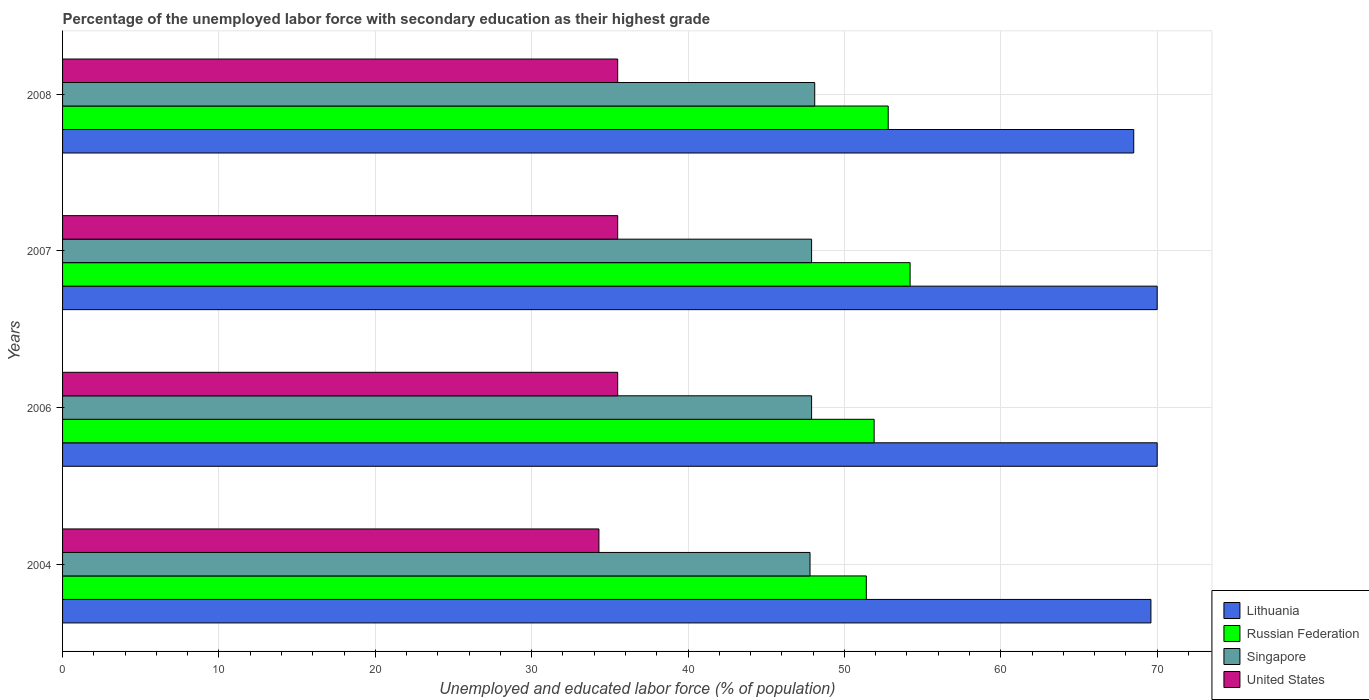Are the number of bars on each tick of the Y-axis equal?
Your answer should be compact. Yes. How many bars are there on the 4th tick from the top?
Make the answer very short. 4. What is the label of the 3rd group of bars from the top?
Keep it short and to the point. 2006. What is the percentage of the unemployed labor force with secondary education in Russian Federation in 2007?
Provide a succinct answer. 54.2. Across all years, what is the minimum percentage of the unemployed labor force with secondary education in Singapore?
Your response must be concise. 47.8. In which year was the percentage of the unemployed labor force with secondary education in Lithuania minimum?
Your answer should be compact. 2008. What is the total percentage of the unemployed labor force with secondary education in Singapore in the graph?
Provide a short and direct response. 191.7. What is the difference between the percentage of the unemployed labor force with secondary education in Singapore in 2006 and that in 2007?
Provide a short and direct response. 0. What is the difference between the percentage of the unemployed labor force with secondary education in United States in 2004 and the percentage of the unemployed labor force with secondary education in Singapore in 2007?
Offer a terse response. -13.6. What is the average percentage of the unemployed labor force with secondary education in Russian Federation per year?
Provide a short and direct response. 52.58. In the year 2006, what is the difference between the percentage of the unemployed labor force with secondary education in Lithuania and percentage of the unemployed labor force with secondary education in United States?
Make the answer very short. 34.5. In how many years, is the percentage of the unemployed labor force with secondary education in Singapore greater than 24 %?
Your response must be concise. 4. What is the ratio of the percentage of the unemployed labor force with secondary education in Russian Federation in 2004 to that in 2006?
Give a very brief answer. 0.99. In how many years, is the percentage of the unemployed labor force with secondary education in United States greater than the average percentage of the unemployed labor force with secondary education in United States taken over all years?
Provide a succinct answer. 3. What does the 4th bar from the top in 2008 represents?
Offer a very short reply. Lithuania. What does the 2nd bar from the bottom in 2008 represents?
Your response must be concise. Russian Federation. How many bars are there?
Keep it short and to the point. 16. How many years are there in the graph?
Provide a succinct answer. 4. Are the values on the major ticks of X-axis written in scientific E-notation?
Offer a terse response. No. Does the graph contain any zero values?
Offer a very short reply. No. Does the graph contain grids?
Your response must be concise. Yes. What is the title of the graph?
Offer a terse response. Percentage of the unemployed labor force with secondary education as their highest grade. Does "Tunisia" appear as one of the legend labels in the graph?
Your answer should be compact. No. What is the label or title of the X-axis?
Offer a terse response. Unemployed and educated labor force (% of population). What is the Unemployed and educated labor force (% of population) in Lithuania in 2004?
Offer a terse response. 69.6. What is the Unemployed and educated labor force (% of population) of Russian Federation in 2004?
Your answer should be very brief. 51.4. What is the Unemployed and educated labor force (% of population) in Singapore in 2004?
Your answer should be very brief. 47.8. What is the Unemployed and educated labor force (% of population) in United States in 2004?
Give a very brief answer. 34.3. What is the Unemployed and educated labor force (% of population) of Lithuania in 2006?
Provide a succinct answer. 70. What is the Unemployed and educated labor force (% of population) in Russian Federation in 2006?
Ensure brevity in your answer.  51.9. What is the Unemployed and educated labor force (% of population) of Singapore in 2006?
Ensure brevity in your answer.  47.9. What is the Unemployed and educated labor force (% of population) of United States in 2006?
Provide a succinct answer. 35.5. What is the Unemployed and educated labor force (% of population) of Russian Federation in 2007?
Ensure brevity in your answer.  54.2. What is the Unemployed and educated labor force (% of population) in Singapore in 2007?
Keep it short and to the point. 47.9. What is the Unemployed and educated labor force (% of population) in United States in 2007?
Make the answer very short. 35.5. What is the Unemployed and educated labor force (% of population) of Lithuania in 2008?
Make the answer very short. 68.5. What is the Unemployed and educated labor force (% of population) in Russian Federation in 2008?
Make the answer very short. 52.8. What is the Unemployed and educated labor force (% of population) in Singapore in 2008?
Give a very brief answer. 48.1. What is the Unemployed and educated labor force (% of population) of United States in 2008?
Offer a terse response. 35.5. Across all years, what is the maximum Unemployed and educated labor force (% of population) in Lithuania?
Provide a succinct answer. 70. Across all years, what is the maximum Unemployed and educated labor force (% of population) in Russian Federation?
Provide a short and direct response. 54.2. Across all years, what is the maximum Unemployed and educated labor force (% of population) in Singapore?
Ensure brevity in your answer.  48.1. Across all years, what is the maximum Unemployed and educated labor force (% of population) in United States?
Provide a succinct answer. 35.5. Across all years, what is the minimum Unemployed and educated labor force (% of population) of Lithuania?
Provide a short and direct response. 68.5. Across all years, what is the minimum Unemployed and educated labor force (% of population) in Russian Federation?
Your response must be concise. 51.4. Across all years, what is the minimum Unemployed and educated labor force (% of population) of Singapore?
Your response must be concise. 47.8. Across all years, what is the minimum Unemployed and educated labor force (% of population) in United States?
Offer a very short reply. 34.3. What is the total Unemployed and educated labor force (% of population) in Lithuania in the graph?
Offer a very short reply. 278.1. What is the total Unemployed and educated labor force (% of population) in Russian Federation in the graph?
Give a very brief answer. 210.3. What is the total Unemployed and educated labor force (% of population) in Singapore in the graph?
Offer a very short reply. 191.7. What is the total Unemployed and educated labor force (% of population) of United States in the graph?
Provide a short and direct response. 140.8. What is the difference between the Unemployed and educated labor force (% of population) in Lithuania in 2004 and that in 2006?
Make the answer very short. -0.4. What is the difference between the Unemployed and educated labor force (% of population) in Russian Federation in 2004 and that in 2006?
Give a very brief answer. -0.5. What is the difference between the Unemployed and educated labor force (% of population) of Lithuania in 2004 and that in 2007?
Make the answer very short. -0.4. What is the difference between the Unemployed and educated labor force (% of population) in Russian Federation in 2004 and that in 2007?
Provide a succinct answer. -2.8. What is the difference between the Unemployed and educated labor force (% of population) of United States in 2004 and that in 2007?
Provide a short and direct response. -1.2. What is the difference between the Unemployed and educated labor force (% of population) of Singapore in 2004 and that in 2008?
Provide a short and direct response. -0.3. What is the difference between the Unemployed and educated labor force (% of population) of Russian Federation in 2006 and that in 2007?
Offer a very short reply. -2.3. What is the difference between the Unemployed and educated labor force (% of population) in Lithuania in 2006 and that in 2008?
Ensure brevity in your answer.  1.5. What is the difference between the Unemployed and educated labor force (% of population) in Singapore in 2007 and that in 2008?
Make the answer very short. -0.2. What is the difference between the Unemployed and educated labor force (% of population) of Lithuania in 2004 and the Unemployed and educated labor force (% of population) of Russian Federation in 2006?
Offer a terse response. 17.7. What is the difference between the Unemployed and educated labor force (% of population) in Lithuania in 2004 and the Unemployed and educated labor force (% of population) in Singapore in 2006?
Ensure brevity in your answer.  21.7. What is the difference between the Unemployed and educated labor force (% of population) in Lithuania in 2004 and the Unemployed and educated labor force (% of population) in United States in 2006?
Your answer should be compact. 34.1. What is the difference between the Unemployed and educated labor force (% of population) in Lithuania in 2004 and the Unemployed and educated labor force (% of population) in Russian Federation in 2007?
Ensure brevity in your answer.  15.4. What is the difference between the Unemployed and educated labor force (% of population) of Lithuania in 2004 and the Unemployed and educated labor force (% of population) of Singapore in 2007?
Your response must be concise. 21.7. What is the difference between the Unemployed and educated labor force (% of population) in Lithuania in 2004 and the Unemployed and educated labor force (% of population) in United States in 2007?
Offer a very short reply. 34.1. What is the difference between the Unemployed and educated labor force (% of population) in Russian Federation in 2004 and the Unemployed and educated labor force (% of population) in United States in 2007?
Your answer should be very brief. 15.9. What is the difference between the Unemployed and educated labor force (% of population) in Lithuania in 2004 and the Unemployed and educated labor force (% of population) in Russian Federation in 2008?
Provide a short and direct response. 16.8. What is the difference between the Unemployed and educated labor force (% of population) of Lithuania in 2004 and the Unemployed and educated labor force (% of population) of Singapore in 2008?
Ensure brevity in your answer.  21.5. What is the difference between the Unemployed and educated labor force (% of population) of Lithuania in 2004 and the Unemployed and educated labor force (% of population) of United States in 2008?
Keep it short and to the point. 34.1. What is the difference between the Unemployed and educated labor force (% of population) of Lithuania in 2006 and the Unemployed and educated labor force (% of population) of Russian Federation in 2007?
Offer a very short reply. 15.8. What is the difference between the Unemployed and educated labor force (% of population) in Lithuania in 2006 and the Unemployed and educated labor force (% of population) in Singapore in 2007?
Your answer should be compact. 22.1. What is the difference between the Unemployed and educated labor force (% of population) in Lithuania in 2006 and the Unemployed and educated labor force (% of population) in United States in 2007?
Provide a short and direct response. 34.5. What is the difference between the Unemployed and educated labor force (% of population) of Russian Federation in 2006 and the Unemployed and educated labor force (% of population) of Singapore in 2007?
Your answer should be compact. 4. What is the difference between the Unemployed and educated labor force (% of population) in Singapore in 2006 and the Unemployed and educated labor force (% of population) in United States in 2007?
Provide a short and direct response. 12.4. What is the difference between the Unemployed and educated labor force (% of population) of Lithuania in 2006 and the Unemployed and educated labor force (% of population) of Singapore in 2008?
Provide a short and direct response. 21.9. What is the difference between the Unemployed and educated labor force (% of population) in Lithuania in 2006 and the Unemployed and educated labor force (% of population) in United States in 2008?
Your answer should be compact. 34.5. What is the difference between the Unemployed and educated labor force (% of population) in Lithuania in 2007 and the Unemployed and educated labor force (% of population) in Singapore in 2008?
Your answer should be very brief. 21.9. What is the difference between the Unemployed and educated labor force (% of population) in Lithuania in 2007 and the Unemployed and educated labor force (% of population) in United States in 2008?
Keep it short and to the point. 34.5. What is the difference between the Unemployed and educated labor force (% of population) in Russian Federation in 2007 and the Unemployed and educated labor force (% of population) in Singapore in 2008?
Provide a succinct answer. 6.1. What is the difference between the Unemployed and educated labor force (% of population) of Russian Federation in 2007 and the Unemployed and educated labor force (% of population) of United States in 2008?
Make the answer very short. 18.7. What is the average Unemployed and educated labor force (% of population) in Lithuania per year?
Your answer should be compact. 69.53. What is the average Unemployed and educated labor force (% of population) of Russian Federation per year?
Your response must be concise. 52.58. What is the average Unemployed and educated labor force (% of population) in Singapore per year?
Ensure brevity in your answer.  47.92. What is the average Unemployed and educated labor force (% of population) in United States per year?
Give a very brief answer. 35.2. In the year 2004, what is the difference between the Unemployed and educated labor force (% of population) in Lithuania and Unemployed and educated labor force (% of population) in Singapore?
Your response must be concise. 21.8. In the year 2004, what is the difference between the Unemployed and educated labor force (% of population) of Lithuania and Unemployed and educated labor force (% of population) of United States?
Keep it short and to the point. 35.3. In the year 2004, what is the difference between the Unemployed and educated labor force (% of population) in Russian Federation and Unemployed and educated labor force (% of population) in Singapore?
Your answer should be very brief. 3.6. In the year 2006, what is the difference between the Unemployed and educated labor force (% of population) of Lithuania and Unemployed and educated labor force (% of population) of Singapore?
Provide a short and direct response. 22.1. In the year 2006, what is the difference between the Unemployed and educated labor force (% of population) in Lithuania and Unemployed and educated labor force (% of population) in United States?
Keep it short and to the point. 34.5. In the year 2006, what is the difference between the Unemployed and educated labor force (% of population) in Russian Federation and Unemployed and educated labor force (% of population) in United States?
Your answer should be compact. 16.4. In the year 2007, what is the difference between the Unemployed and educated labor force (% of population) in Lithuania and Unemployed and educated labor force (% of population) in Russian Federation?
Make the answer very short. 15.8. In the year 2007, what is the difference between the Unemployed and educated labor force (% of population) of Lithuania and Unemployed and educated labor force (% of population) of Singapore?
Offer a very short reply. 22.1. In the year 2007, what is the difference between the Unemployed and educated labor force (% of population) of Lithuania and Unemployed and educated labor force (% of population) of United States?
Offer a terse response. 34.5. In the year 2007, what is the difference between the Unemployed and educated labor force (% of population) in Russian Federation and Unemployed and educated labor force (% of population) in Singapore?
Make the answer very short. 6.3. In the year 2007, what is the difference between the Unemployed and educated labor force (% of population) in Russian Federation and Unemployed and educated labor force (% of population) in United States?
Your answer should be very brief. 18.7. In the year 2007, what is the difference between the Unemployed and educated labor force (% of population) of Singapore and Unemployed and educated labor force (% of population) of United States?
Make the answer very short. 12.4. In the year 2008, what is the difference between the Unemployed and educated labor force (% of population) of Lithuania and Unemployed and educated labor force (% of population) of Singapore?
Your response must be concise. 20.4. In the year 2008, what is the difference between the Unemployed and educated labor force (% of population) of Russian Federation and Unemployed and educated labor force (% of population) of United States?
Offer a terse response. 17.3. In the year 2008, what is the difference between the Unemployed and educated labor force (% of population) in Singapore and Unemployed and educated labor force (% of population) in United States?
Keep it short and to the point. 12.6. What is the ratio of the Unemployed and educated labor force (% of population) of Singapore in 2004 to that in 2006?
Your response must be concise. 1. What is the ratio of the Unemployed and educated labor force (% of population) of United States in 2004 to that in 2006?
Make the answer very short. 0.97. What is the ratio of the Unemployed and educated labor force (% of population) in Russian Federation in 2004 to that in 2007?
Your response must be concise. 0.95. What is the ratio of the Unemployed and educated labor force (% of population) of Singapore in 2004 to that in 2007?
Keep it short and to the point. 1. What is the ratio of the Unemployed and educated labor force (% of population) of United States in 2004 to that in 2007?
Make the answer very short. 0.97. What is the ratio of the Unemployed and educated labor force (% of population) in Lithuania in 2004 to that in 2008?
Your response must be concise. 1.02. What is the ratio of the Unemployed and educated labor force (% of population) of Russian Federation in 2004 to that in 2008?
Your answer should be very brief. 0.97. What is the ratio of the Unemployed and educated labor force (% of population) in United States in 2004 to that in 2008?
Keep it short and to the point. 0.97. What is the ratio of the Unemployed and educated labor force (% of population) in Russian Federation in 2006 to that in 2007?
Your answer should be compact. 0.96. What is the ratio of the Unemployed and educated labor force (% of population) of Singapore in 2006 to that in 2007?
Provide a succinct answer. 1. What is the ratio of the Unemployed and educated labor force (% of population) in Lithuania in 2006 to that in 2008?
Make the answer very short. 1.02. What is the ratio of the Unemployed and educated labor force (% of population) in Lithuania in 2007 to that in 2008?
Your response must be concise. 1.02. What is the ratio of the Unemployed and educated labor force (% of population) in Russian Federation in 2007 to that in 2008?
Offer a terse response. 1.03. What is the ratio of the Unemployed and educated labor force (% of population) in Singapore in 2007 to that in 2008?
Your answer should be very brief. 1. What is the ratio of the Unemployed and educated labor force (% of population) in United States in 2007 to that in 2008?
Offer a terse response. 1. What is the difference between the highest and the second highest Unemployed and educated labor force (% of population) of Singapore?
Ensure brevity in your answer.  0.2. What is the difference between the highest and the second highest Unemployed and educated labor force (% of population) of United States?
Ensure brevity in your answer.  0. What is the difference between the highest and the lowest Unemployed and educated labor force (% of population) of Russian Federation?
Keep it short and to the point. 2.8. What is the difference between the highest and the lowest Unemployed and educated labor force (% of population) of Singapore?
Keep it short and to the point. 0.3. 